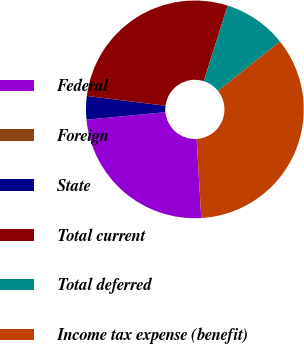Convert chart. <chart><loc_0><loc_0><loc_500><loc_500><pie_chart><fcel>Federal<fcel>Foreign<fcel>State<fcel>Total current<fcel>Total deferred<fcel>Income tax expense (benefit)<nl><fcel>24.42%<fcel>0.01%<fcel>3.48%<fcel>27.9%<fcel>9.41%<fcel>34.79%<nl></chart> 